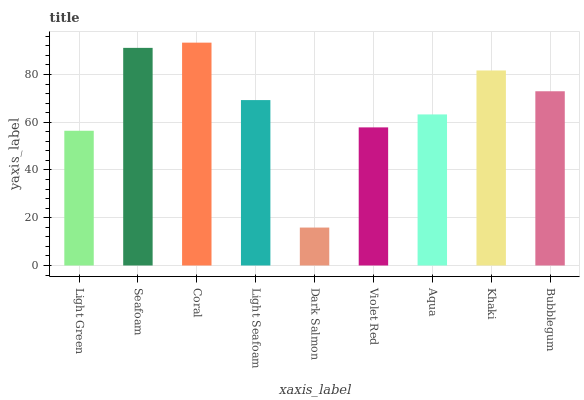Is Dark Salmon the minimum?
Answer yes or no. Yes. Is Coral the maximum?
Answer yes or no. Yes. Is Seafoam the minimum?
Answer yes or no. No. Is Seafoam the maximum?
Answer yes or no. No. Is Seafoam greater than Light Green?
Answer yes or no. Yes. Is Light Green less than Seafoam?
Answer yes or no. Yes. Is Light Green greater than Seafoam?
Answer yes or no. No. Is Seafoam less than Light Green?
Answer yes or no. No. Is Light Seafoam the high median?
Answer yes or no. Yes. Is Light Seafoam the low median?
Answer yes or no. Yes. Is Coral the high median?
Answer yes or no. No. Is Khaki the low median?
Answer yes or no. No. 